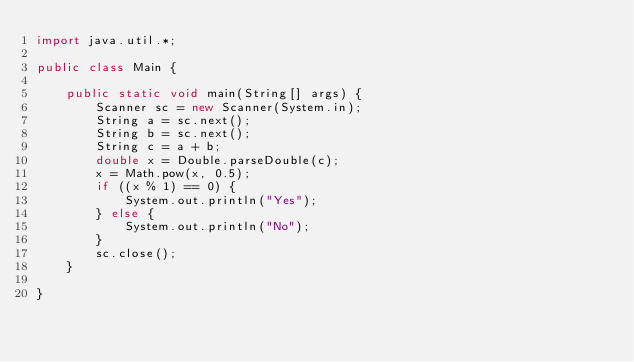Convert code to text. <code><loc_0><loc_0><loc_500><loc_500><_Java_>import java.util.*;

public class Main {

	public static void main(String[] args) {
		Scanner sc = new Scanner(System.in);
		String a = sc.next();
		String b = sc.next();
		String c = a + b;
		double x = Double.parseDouble(c);
		x = Math.pow(x, 0.5);
		if ((x % 1) == 0) {
			System.out.println("Yes");
		} else {
			System.out.println("No");
		}
		sc.close();
	}

}</code> 